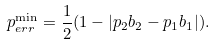Convert formula to latex. <formula><loc_0><loc_0><loc_500><loc_500>p ^ { \min } _ { e r r } = \frac { 1 } { 2 } ( 1 - | p _ { 2 } b _ { 2 } - p _ { 1 } b _ { 1 } | ) .</formula> 